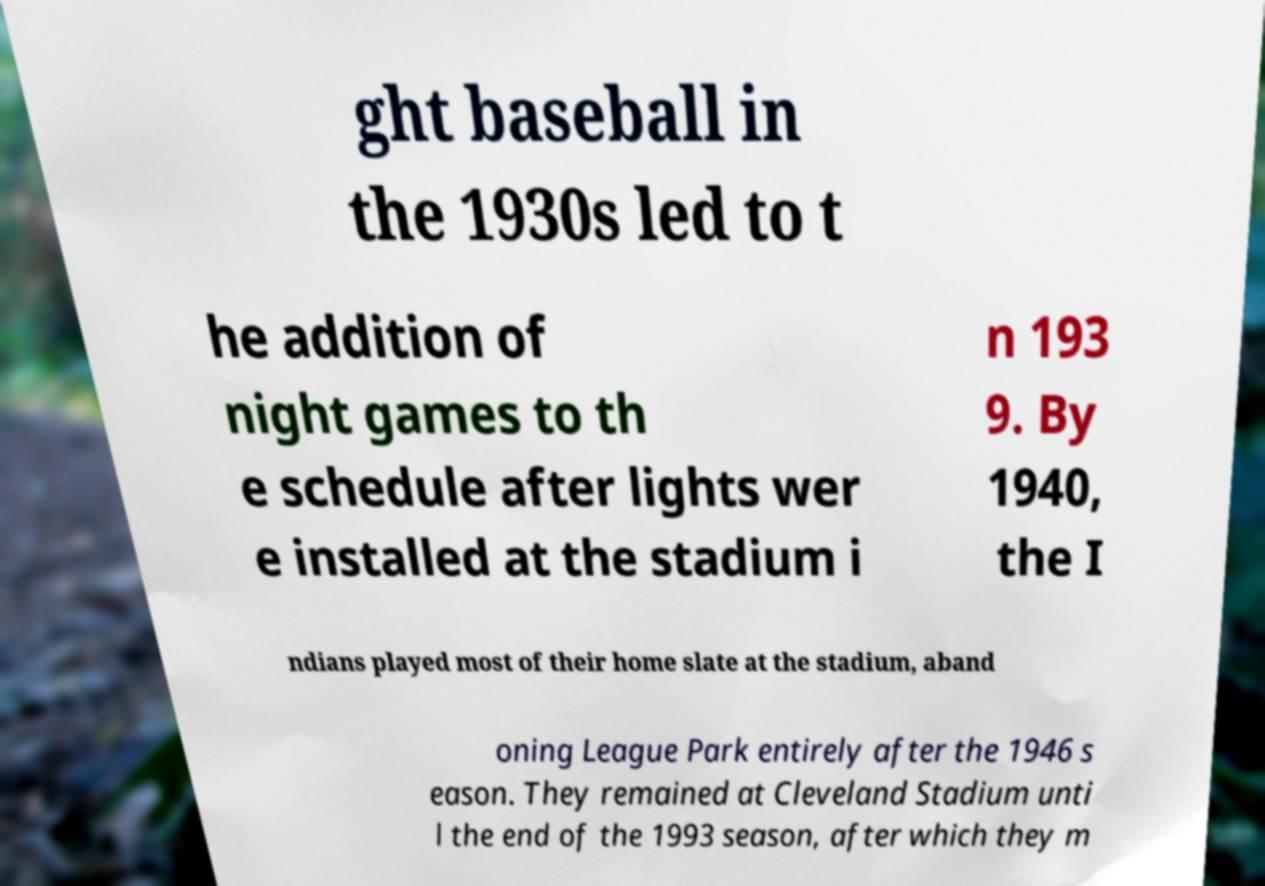Could you extract and type out the text from this image? ght baseball in the 1930s led to t he addition of night games to th e schedule after lights wer e installed at the stadium i n 193 9. By 1940, the I ndians played most of their home slate at the stadium, aband oning League Park entirely after the 1946 s eason. They remained at Cleveland Stadium unti l the end of the 1993 season, after which they m 